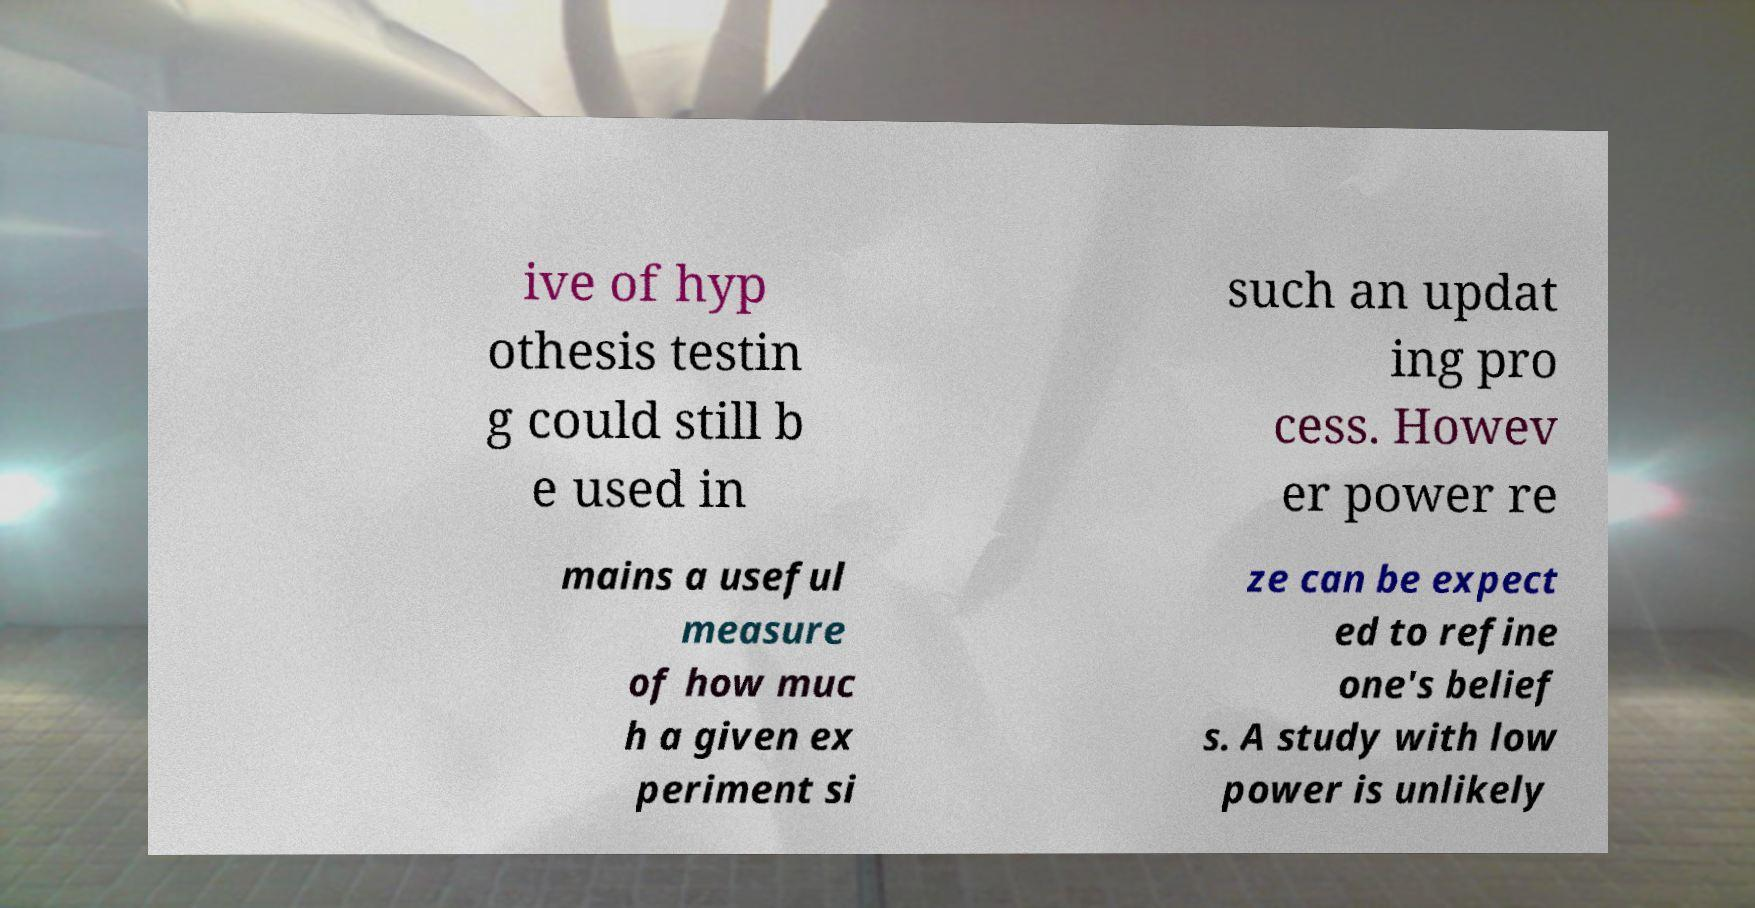There's text embedded in this image that I need extracted. Can you transcribe it verbatim? ive of hyp othesis testin g could still b e used in such an updat ing pro cess. Howev er power re mains a useful measure of how muc h a given ex periment si ze can be expect ed to refine one's belief s. A study with low power is unlikely 